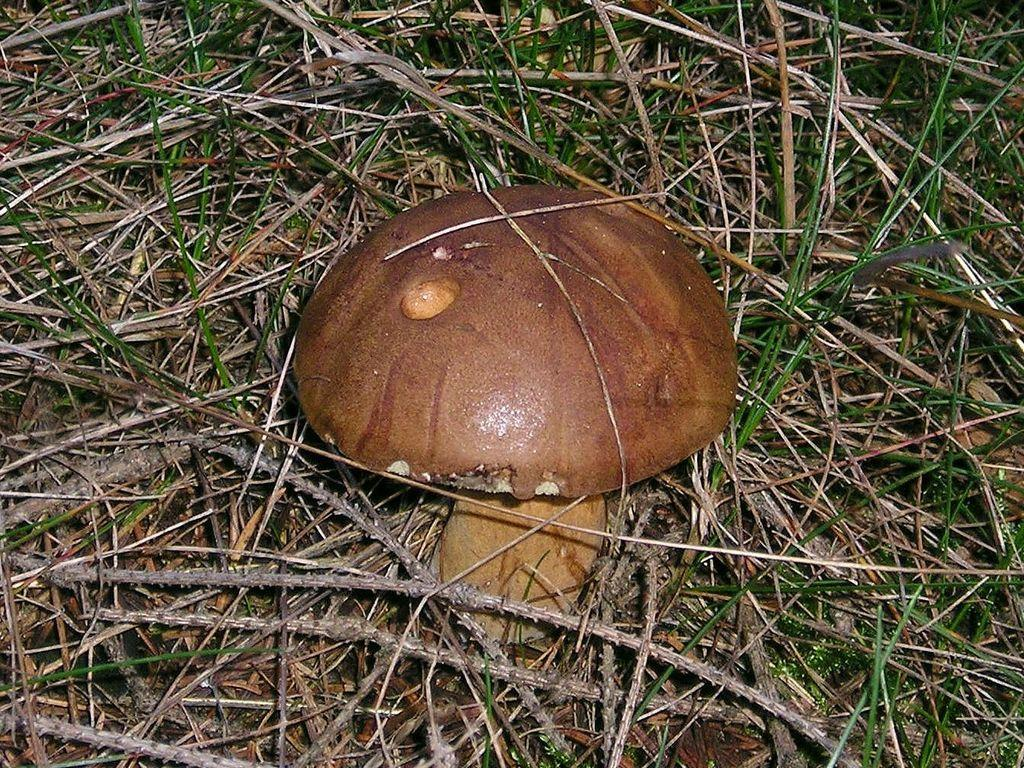What is the main subject of the image? There is a mushroom in the image. Where is the mushroom located? The mushroom is on the land. What type of vegetation can be seen in the image? There is grass in the image. What other natural elements are present in the image? Dried sticks are present in the image. How many people are saying good-bye to the mushroom in the image? There are no people present in the image, and therefore no one is saying good-bye to the mushroom. What type of tomatoes can be seen growing near the mushroom in the image? There are no tomatoes present in the image; only the mushroom, grass, and dried sticks can be seen. 